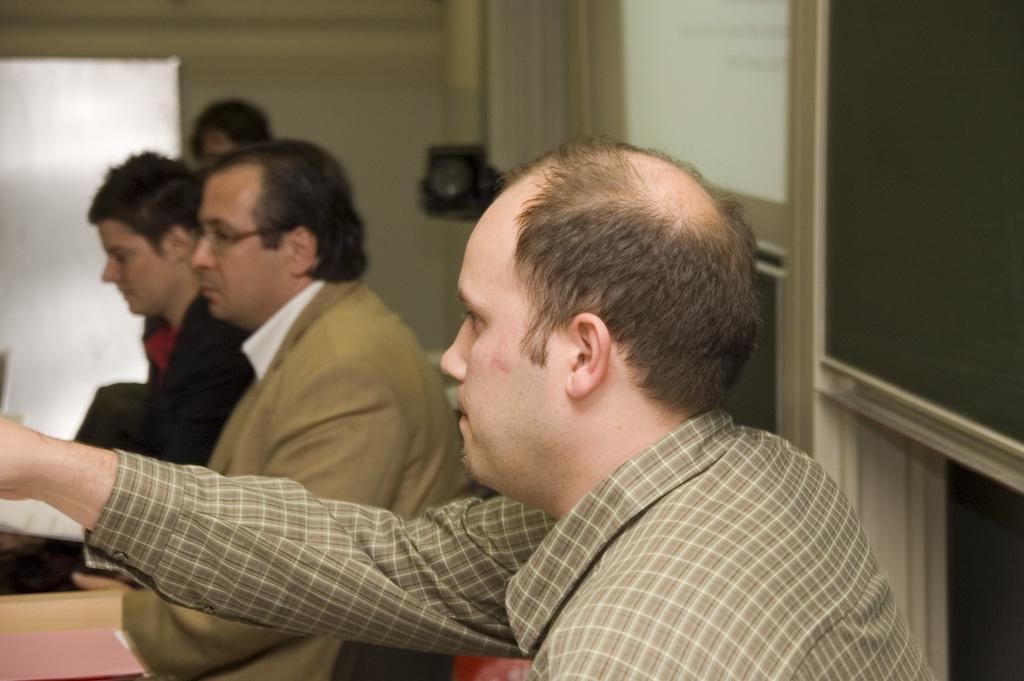Describe this image in one or two sentences. In this image there are four men, there is an object towards the left of the image, there is a wall towards the top of the image, there is a wall towards the right of the image, there is a black color object behind the persons. 